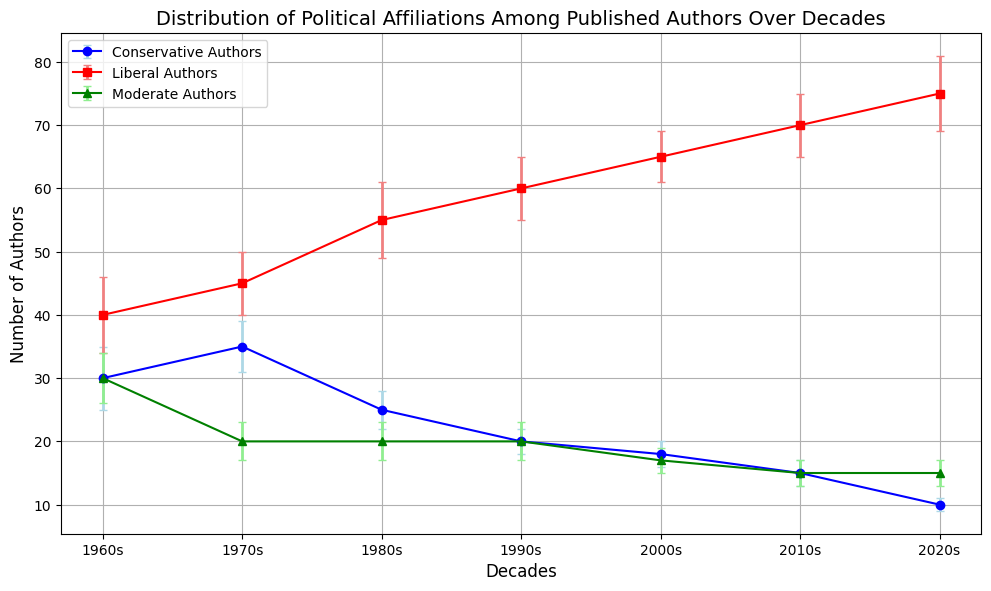Which decade had the most number of Conservative Authors? Find the decade with the peak value in the blue line, which represents conservative authors. According to the figure, the peak occurs in the 1970s.
Answer: 1970s Between the 1980s and the 2020s, what is the difference in the number of Moderate Authors? Look at the green line, noting the values at the 1980s (20) and the 2020s (15) and subtract them: 20 - 15.
Answer: 5 What is the average number of Liberal Authors in the 1990s and 2000s? Note the number of Liberal Authors in the 1990s (60) and 2000s (65). Add them together and divide by 2: (60 + 65) / 2.
Answer: 62.5 Which political affiliation shows the greatest decline from the 1960s to the 2020s? By comparing all three lines, the blue line (Conservative Authors) shows the most significant decline from 30 in the 1960s to 10 in the 2020s.
Answer: Conservative Authors In which decade was the difference between Liberal and Conservative Authors the highest? Calculate the differences for each decade and find the maximum. The differences are: 
1960s: 40-30 = 10, 
1970s: 45-35 = 10, 
1980s: 55-25 = 30, 
1990s: 60-20 = 40, 
2000s: 65-18 = 47, 
2010s: 70-15 = 55, 
2020s: 75-10 = 65. Thus, the 2020s have the highest difference.
Answer: 2020s Which color line represents Moderate Authors in the figure? Identify the line corresponding to Moderates based on color. The green line represents Moderate Authors.
Answer: Green How consistent are the error margins for Conservative Authors compared to Liberal Authors across the decades? Look at the error bars' size for Conservatives (blue) and Liberals (red). The Conservative Authors' error margins are consistently smaller, typically around 1-5, whereas Liberal Authors' errors range from 4-6 and are larger and more variable.
Answer: Conservative Authors are more consistent In the 2010s, what proportion of authors were Moderate compared to Conservative? Look at the 2010s values: Moderate Authors 15, Conservative Authors 15. The proportion is the ratio 15/15.
Answer: 1 (or equal numbers) By how many did the number of Liberal Authors increase from the 1960s to the 2020s? Identify the values for Liberal Authors in the 1960s (40) and 2020s (75), then subtract: 75 - 40.
Answer: 35 